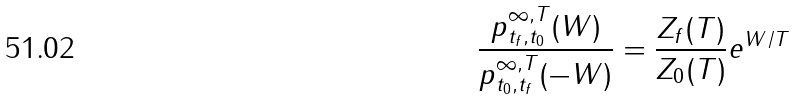Convert formula to latex. <formula><loc_0><loc_0><loc_500><loc_500>\frac { p _ { t _ { f } , t _ { 0 } } ^ { \infty , T } ( W ) } { p _ { t _ { 0 } , t _ { f } } ^ { \infty , T } ( - W ) } = \frac { Z _ { f } ( T ) } { Z _ { 0 } ( T ) } e ^ { W / T }</formula> 